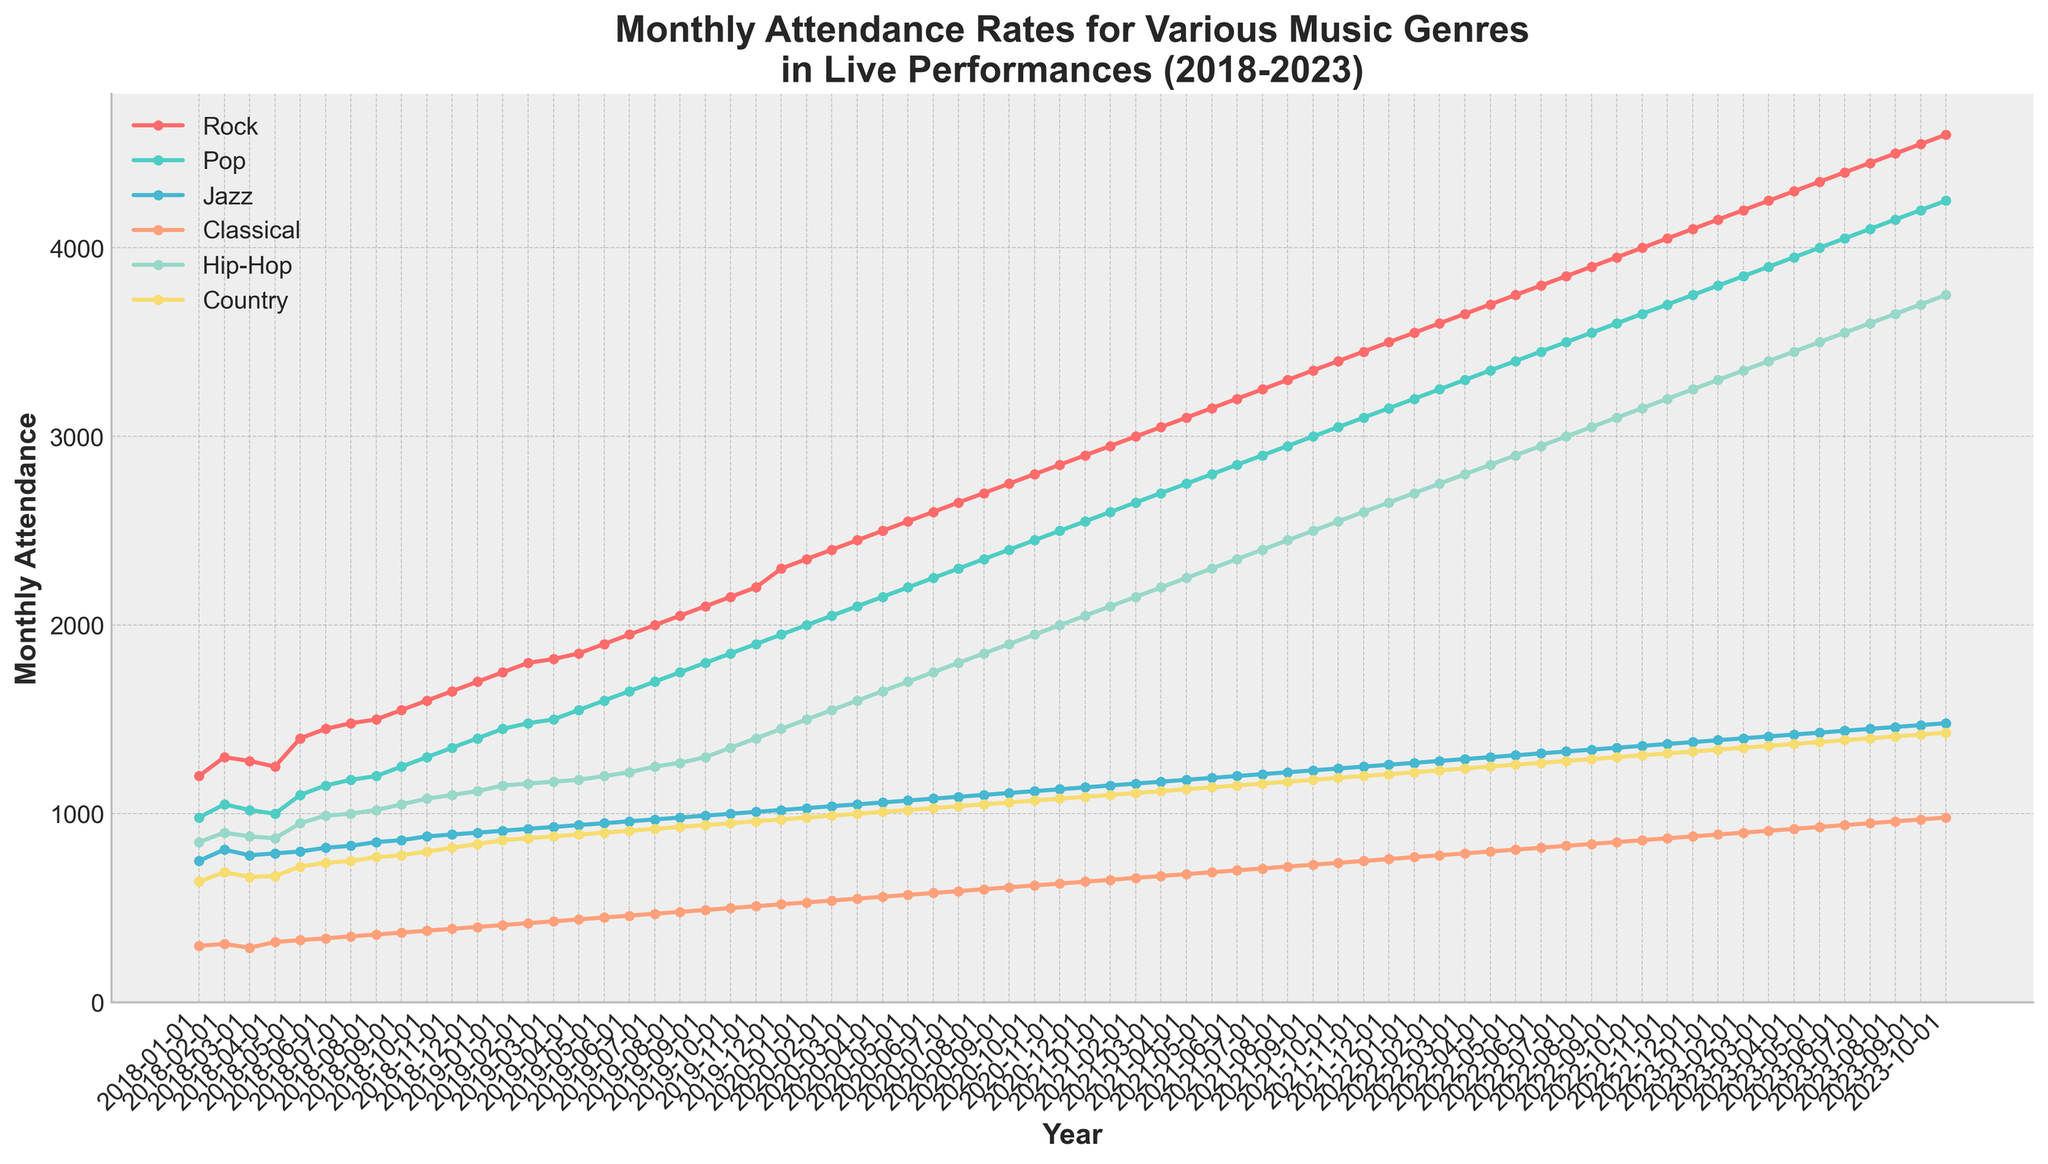What is the title of the plot? The title is usually located at the top of the figure, it summarizes the main content of the plot.
Answer: Monthly Attendance Rates for Various Music Genres in Live Performances (2018-2023) Which genre has the overall highest attendance in October 2023? To answer this, locate the month of October 2023 on the x-axis and observe the y-values of all genres. The genre with the highest y-value has the highest attendance.
Answer: Rock What music genre shows the least fluctuation in attendance over the five years? Look at the plot lines for all genres and compare their fluctuations. The line that remains relatively stable and does not show large spikes or drops represents the genre with the least fluctuation.
Answer: Classical By how much has the attendance for Rock increased from January 2018 to October 2023? Find the attendance value for Rock in January 2018 and in October 2023, then subtract the former from the latter to find the increase. Rock's attendance was 1200 in January 2018 and 4600 in October 2023, so the increase is 4600 - 1200.
Answer: 3400 Which genre had the highest growth rate in attendance over the period? A detailed view of the steepness of each genre's line will indicate the growth rate. Calculating the percentage increase from 2018 to 2023 for all genres will show that Rock has the steepest slope.
Answer: Rock What trend can you observe in the attendance rate for Hip-Hop over the five years? To observe a trend, follow the line for Hip-Hop from the start in 2018 through to 2023. Notice if the line is rising, falling, or stable over this period.
Answer: Increasing Which month generally shows the highest attendance for all genres? Look across all the years on the x-axis for the highest point for each genre's line. Check in which month the y-values peak the most for all genres.
Answer: December How does attendance for Country in July 2023 compare to Hip-Hop in July 2023? Locate July 2023 on the x-axis and compare the y-values for Country and Hip-Hop. Country is lower than Hip-Hop in attendance for that month.
Answer: Hip-Hop has higher attendance What is the average monthly attendance for Pop in 2022? Sum the attendance values for Pop for each month in 2022 and divide by 12. The monthly values are: 3200, 3250, 3300, 3350, 3400, 3450, 3500, 3550, 3600, 3650, 3700, and 3750. The sum is 41800; divide by 12 to get the average.
Answer: 3483 Which genre had the lowest attendance in January 2018, and how much was it? Look for the lowest point among all genres in January 2018. Classical has the lowest attendance for January 2018, at 300.
Answer: Classical, 300 